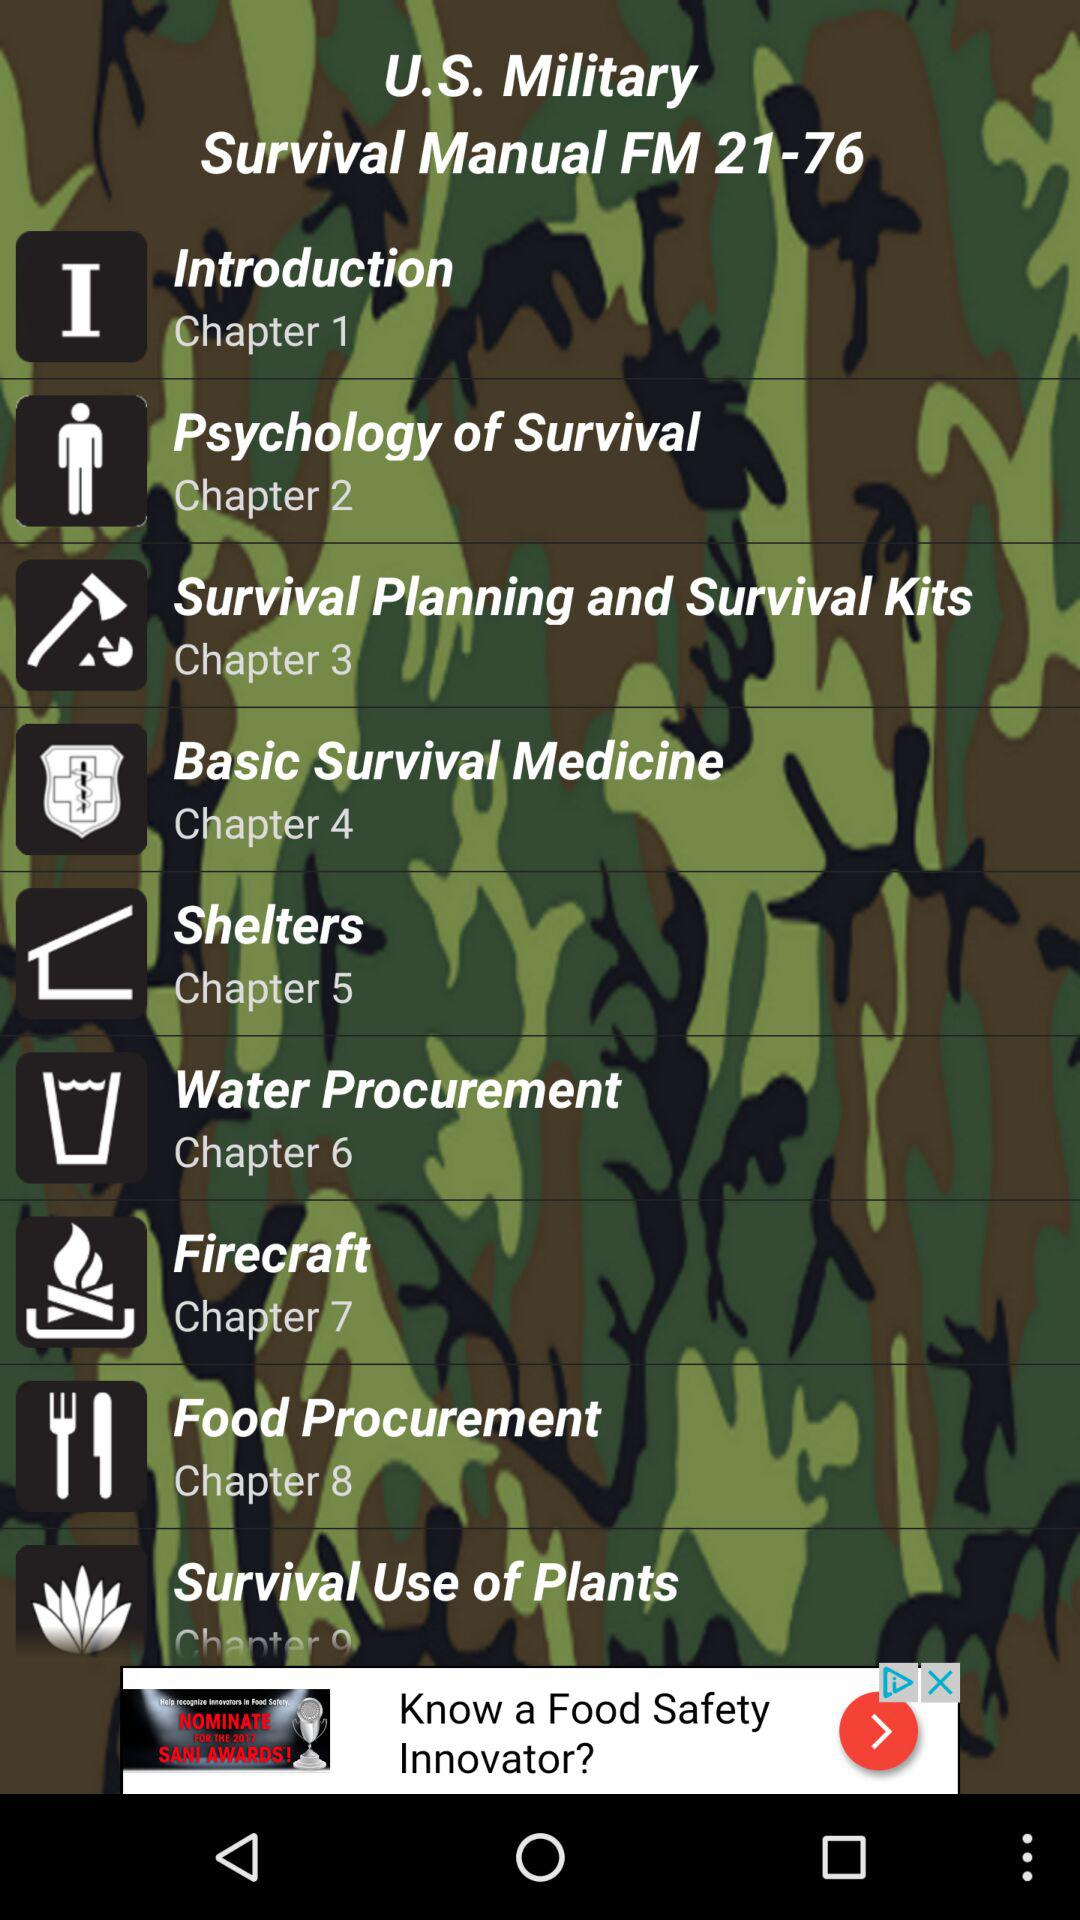What chapter is about "Firecraft"? The chapter about "Firecraft" is 7. 